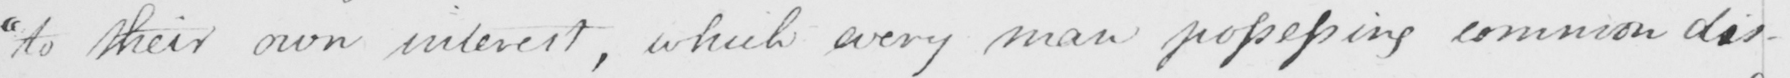Can you tell me what this handwritten text says? " to their own interest , which every man possessing common dis- 